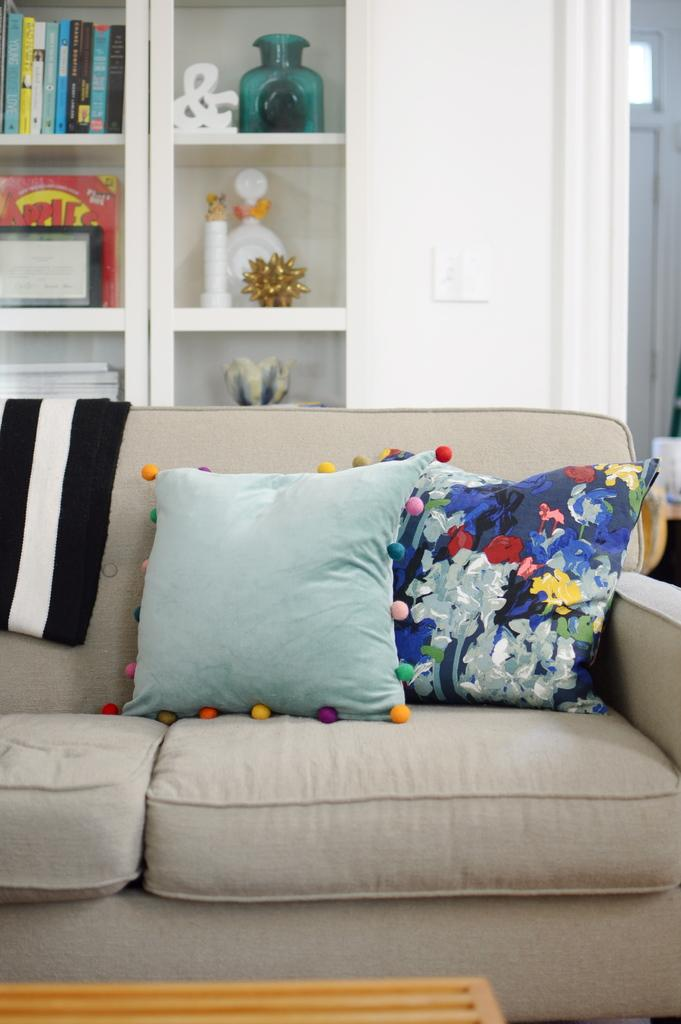What is the person in the image holding? The person is holding a camera. What is the person doing with the camera? The person is taking a picture. What can be seen in the background of the image? There is a building in the background. What type of bone can be seen in the image? There is no bone present in the image; it features a person taking a picture with a camera. --- Facts: 1. There is a person sitting on a chair in the image. 2. The person is reading a book. 3. There is a table next to the chair. Absurd Topics: dance, ocean, bicycle Conversation: What is the person in the image doing? The person is sitting on a chair and reading a book. What object is next to the chair in the image? There is a table next to the chair. Reasoning: Let's think step by step in order to produce the conversation. We start by identifying the main subject in the image, which is the person sitting on a chair. Then, we expand the conversation to include the action the person is performing, which is reading a book. Finally, we mention the object next to the chair, which is a table. Absurd Question/Answer: Can you see the person riding a bicycle in the image? No, there is no bicycle present in the image. The person is sitting on a chair and reading a book. --- Facts: 1. There is a cat sitting on a table in the image. 2. There is a vase with flowers on the table. Absurd Topics: bird, tree, car Conversation: What animal is sitting on the table in the image? There is a cat sitting on the table. What is on the table with the cat? There is a vase with flowers on the table. Reasoning: Let's think step by step in order to produce the conversation. We start by identifying the main subject in the image, which is the cat sitting on a table. Then, we expand the conversation to include the object on the table with the cat, which is a vase with flowers. Absurd Question/Answer: Can you see a bird sitting on the tree in the image? There is no tree or bird present in the image. The image features a cat sitting on a vase with flowers on a table. --- Facts: 1. There is a group of people standing in front of a car in the image. 2. The car is red in color. Absurd Topics: snow, ice cream, mountain Conversation: What is the group of people doing in the image? The group of people is standing in front of a car. What color is the car in the image? The car is red in color. Reasoning: Let's think step by step in order to produce 